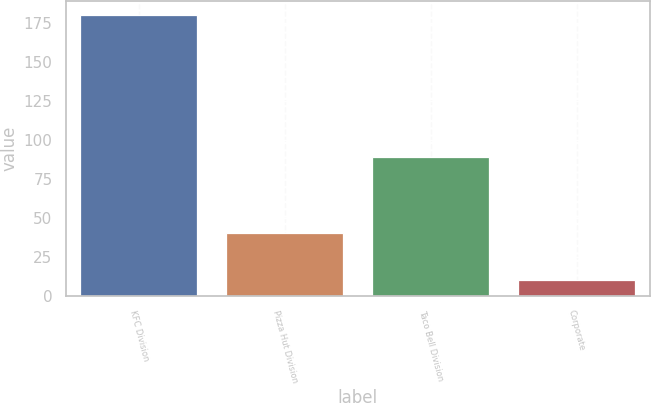Convert chart to OTSL. <chart><loc_0><loc_0><loc_500><loc_500><bar_chart><fcel>KFC Division<fcel>Pizza Hut Division<fcel>Taco Bell Division<fcel>Corporate<nl><fcel>180<fcel>40<fcel>89<fcel>10<nl></chart> 